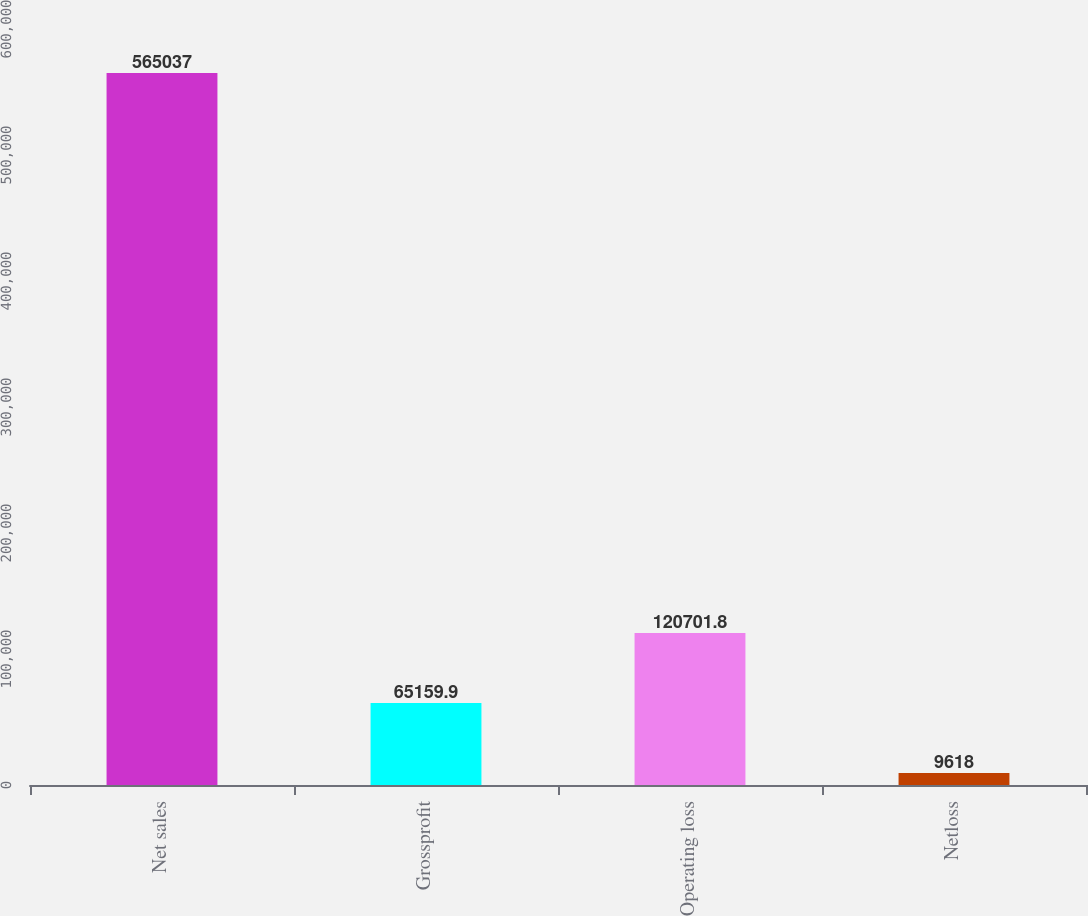Convert chart. <chart><loc_0><loc_0><loc_500><loc_500><bar_chart><fcel>Net sales<fcel>Grossprofit<fcel>Operating loss<fcel>Netloss<nl><fcel>565037<fcel>65159.9<fcel>120702<fcel>9618<nl></chart> 